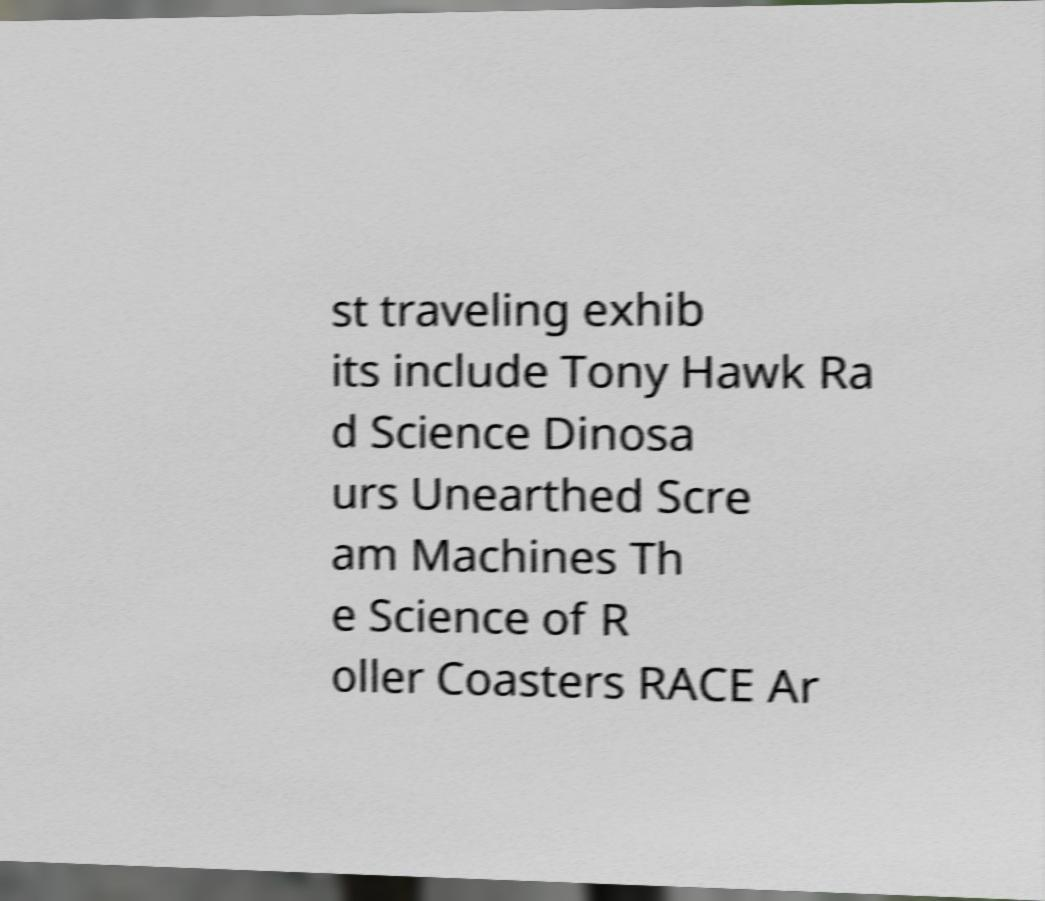Can you read and provide the text displayed in the image?This photo seems to have some interesting text. Can you extract and type it out for me? st traveling exhib its include Tony Hawk Ra d Science Dinosa urs Unearthed Scre am Machines Th e Science of R oller Coasters RACE Ar 